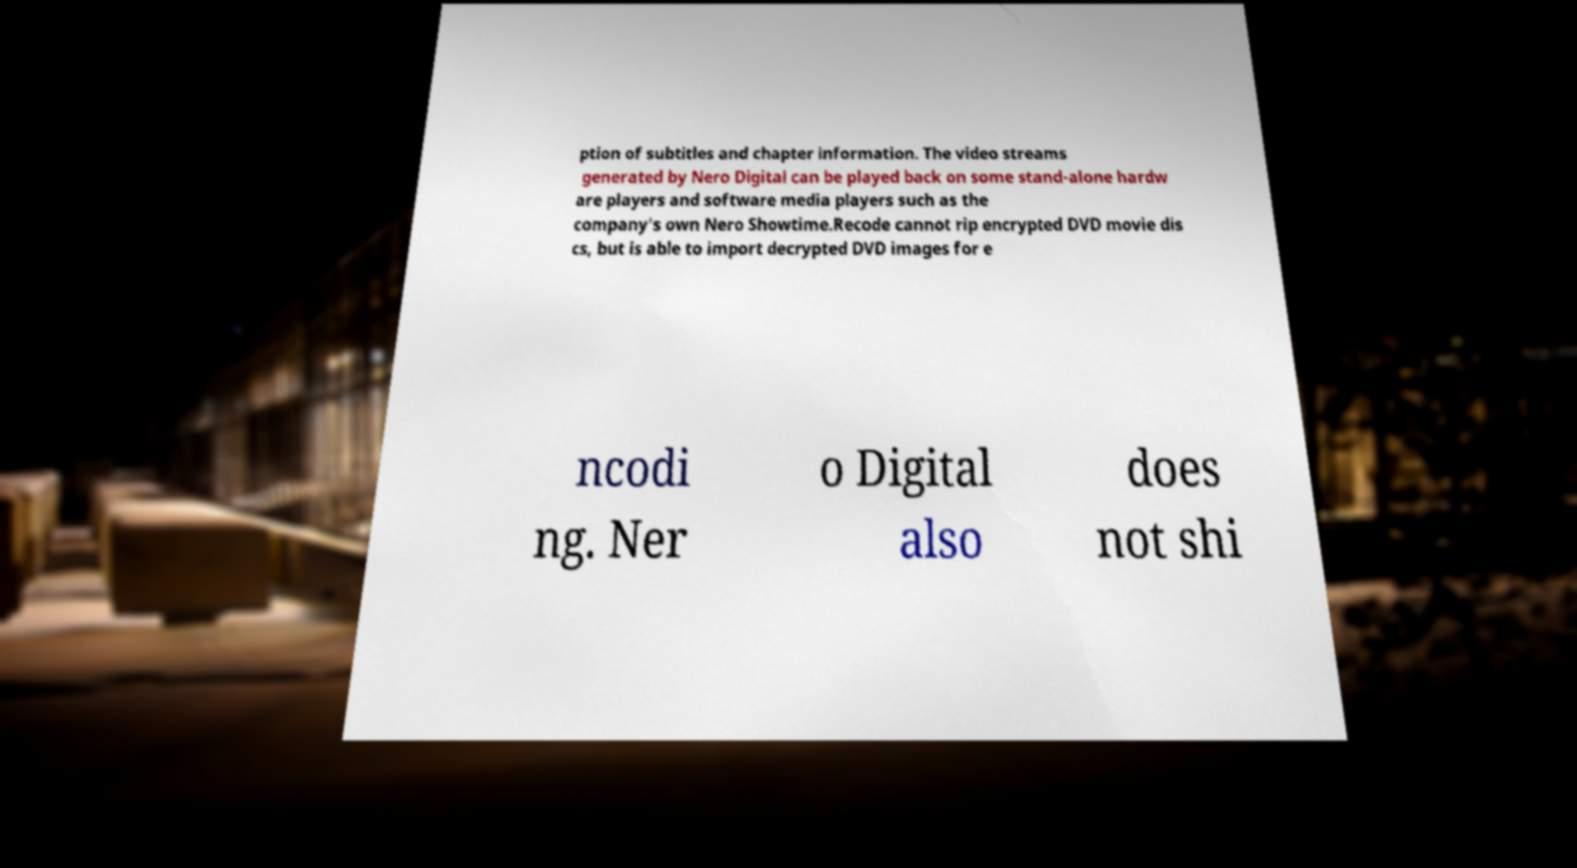Please read and relay the text visible in this image. What does it say? ption of subtitles and chapter information. The video streams generated by Nero Digital can be played back on some stand-alone hardw are players and software media players such as the company's own Nero Showtime.Recode cannot rip encrypted DVD movie dis cs, but is able to import decrypted DVD images for e ncodi ng. Ner o Digital also does not shi 